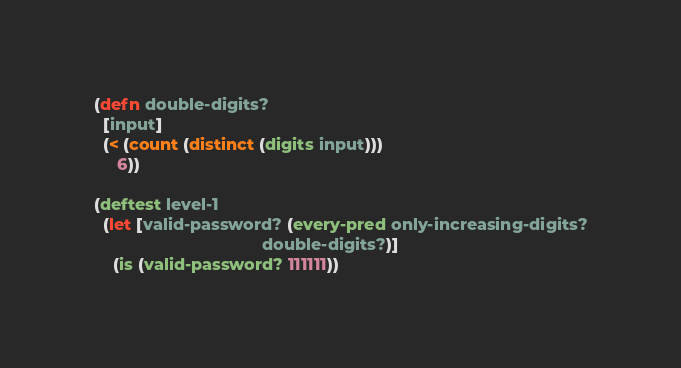Convert code to text. <code><loc_0><loc_0><loc_500><loc_500><_Clojure_>
(defn double-digits?
  [input]
  (< (count (distinct (digits input)))
     6))

(deftest level-1
  (let [valid-password? (every-pred only-increasing-digits?
                                    double-digits?)]
    (is (valid-password? 111111))</code> 